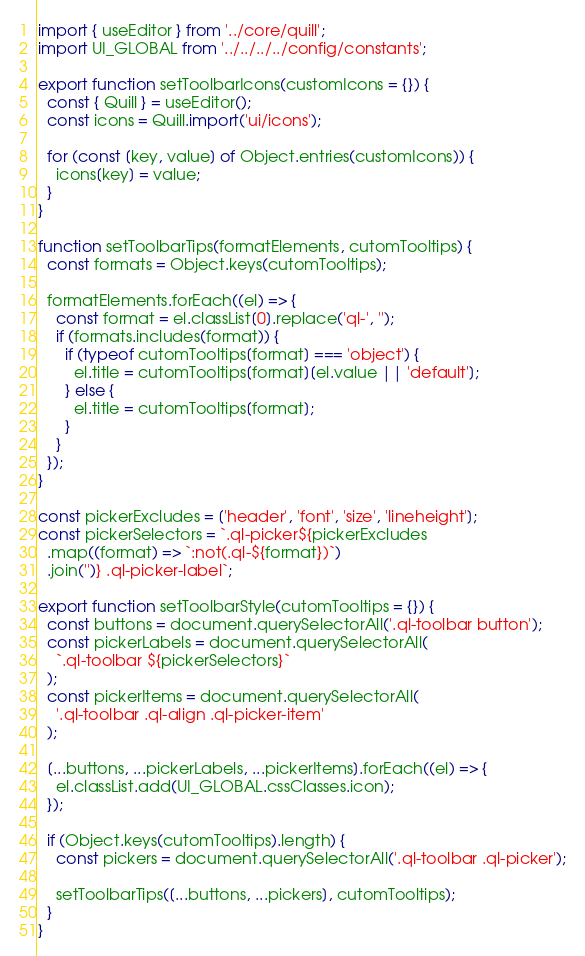<code> <loc_0><loc_0><loc_500><loc_500><_JavaScript_>import { useEditor } from '../core/quill';
import UI_GLOBAL from '../../../../config/constants';

export function setToolbarIcons(customIcons = {}) {
  const { Quill } = useEditor();
  const icons = Quill.import('ui/icons');

  for (const [key, value] of Object.entries(customIcons)) {
    icons[key] = value;
  }
}

function setToolbarTips(formatElements, cutomTooltips) {
  const formats = Object.keys(cutomTooltips);

  formatElements.forEach((el) => {
    const format = el.classList[0].replace('ql-', '');
    if (formats.includes(format)) {
      if (typeof cutomTooltips[format] === 'object') {
        el.title = cutomTooltips[format][el.value || 'default'];
      } else {
        el.title = cutomTooltips[format];
      }
    }
  });
}

const pickerExcludes = ['header', 'font', 'size', 'lineheight'];
const pickerSelectors = `.ql-picker${pickerExcludes
  .map((format) => `:not(.ql-${format})`)
  .join('')} .ql-picker-label`;

export function setToolbarStyle(cutomTooltips = {}) {
  const buttons = document.querySelectorAll('.ql-toolbar button');
  const pickerLabels = document.querySelectorAll(
    `.ql-toolbar ${pickerSelectors}`
  );
  const pickerItems = document.querySelectorAll(
    '.ql-toolbar .ql-align .ql-picker-item'
  );

  [...buttons, ...pickerLabels, ...pickerItems].forEach((el) => {
    el.classList.add(UI_GLOBAL.cssClasses.icon);
  });

  if (Object.keys(cutomTooltips).length) {
    const pickers = document.querySelectorAll('.ql-toolbar .ql-picker');

    setToolbarTips([...buttons, ...pickers], cutomTooltips);
  }
}
</code> 